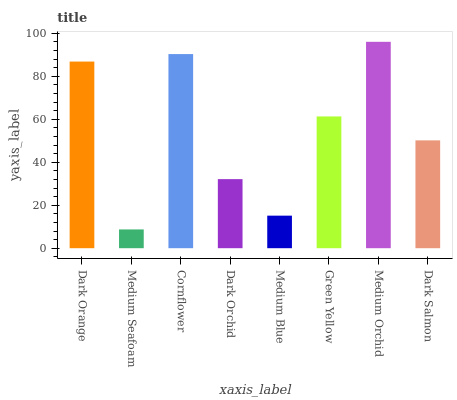Is Medium Seafoam the minimum?
Answer yes or no. Yes. Is Medium Orchid the maximum?
Answer yes or no. Yes. Is Cornflower the minimum?
Answer yes or no. No. Is Cornflower the maximum?
Answer yes or no. No. Is Cornflower greater than Medium Seafoam?
Answer yes or no. Yes. Is Medium Seafoam less than Cornflower?
Answer yes or no. Yes. Is Medium Seafoam greater than Cornflower?
Answer yes or no. No. Is Cornflower less than Medium Seafoam?
Answer yes or no. No. Is Green Yellow the high median?
Answer yes or no. Yes. Is Dark Salmon the low median?
Answer yes or no. Yes. Is Medium Blue the high median?
Answer yes or no. No. Is Dark Orange the low median?
Answer yes or no. No. 